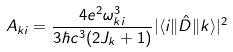<formula> <loc_0><loc_0><loc_500><loc_500>A _ { k i } = \frac { 4 e ^ { 2 } \omega _ { k i } ^ { 3 } } { 3 \hbar { c } ^ { 3 } ( 2 J _ { k } + 1 ) } | \langle i \| \hat { D } \| k \rangle | ^ { 2 }</formula> 